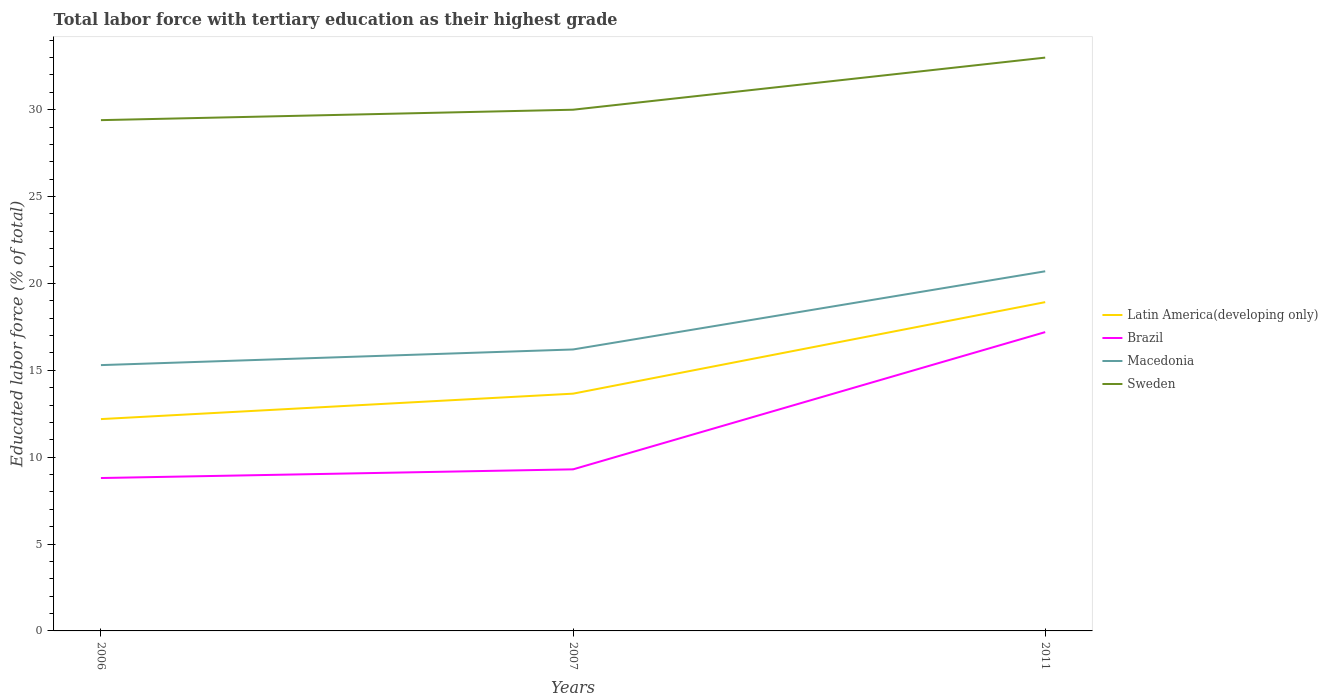How many different coloured lines are there?
Your answer should be very brief. 4. Does the line corresponding to Macedonia intersect with the line corresponding to Brazil?
Offer a terse response. No. Is the number of lines equal to the number of legend labels?
Provide a succinct answer. Yes. Across all years, what is the maximum percentage of male labor force with tertiary education in Brazil?
Offer a terse response. 8.8. What is the total percentage of male labor force with tertiary education in Macedonia in the graph?
Provide a succinct answer. -5.4. What is the difference between the highest and the second highest percentage of male labor force with tertiary education in Latin America(developing only)?
Offer a terse response. 6.73. Is the percentage of male labor force with tertiary education in Macedonia strictly greater than the percentage of male labor force with tertiary education in Sweden over the years?
Your response must be concise. Yes. What is the difference between two consecutive major ticks on the Y-axis?
Your answer should be compact. 5. Are the values on the major ticks of Y-axis written in scientific E-notation?
Make the answer very short. No. Where does the legend appear in the graph?
Keep it short and to the point. Center right. How many legend labels are there?
Your answer should be very brief. 4. What is the title of the graph?
Your answer should be very brief. Total labor force with tertiary education as their highest grade. What is the label or title of the X-axis?
Ensure brevity in your answer.  Years. What is the label or title of the Y-axis?
Your answer should be very brief. Educated labor force (% of total). What is the Educated labor force (% of total) in Latin America(developing only) in 2006?
Give a very brief answer. 12.19. What is the Educated labor force (% of total) in Brazil in 2006?
Offer a terse response. 8.8. What is the Educated labor force (% of total) in Macedonia in 2006?
Offer a terse response. 15.3. What is the Educated labor force (% of total) in Sweden in 2006?
Give a very brief answer. 29.4. What is the Educated labor force (% of total) of Latin America(developing only) in 2007?
Offer a terse response. 13.66. What is the Educated labor force (% of total) in Brazil in 2007?
Your answer should be very brief. 9.3. What is the Educated labor force (% of total) of Macedonia in 2007?
Provide a short and direct response. 16.2. What is the Educated labor force (% of total) in Latin America(developing only) in 2011?
Make the answer very short. 18.92. What is the Educated labor force (% of total) in Brazil in 2011?
Keep it short and to the point. 17.2. What is the Educated labor force (% of total) in Macedonia in 2011?
Your answer should be very brief. 20.7. Across all years, what is the maximum Educated labor force (% of total) of Latin America(developing only)?
Your answer should be compact. 18.92. Across all years, what is the maximum Educated labor force (% of total) of Brazil?
Make the answer very short. 17.2. Across all years, what is the maximum Educated labor force (% of total) of Macedonia?
Keep it short and to the point. 20.7. Across all years, what is the minimum Educated labor force (% of total) of Latin America(developing only)?
Your response must be concise. 12.19. Across all years, what is the minimum Educated labor force (% of total) in Brazil?
Offer a very short reply. 8.8. Across all years, what is the minimum Educated labor force (% of total) of Macedonia?
Offer a very short reply. 15.3. Across all years, what is the minimum Educated labor force (% of total) in Sweden?
Keep it short and to the point. 29.4. What is the total Educated labor force (% of total) of Latin America(developing only) in the graph?
Your response must be concise. 44.77. What is the total Educated labor force (% of total) in Brazil in the graph?
Give a very brief answer. 35.3. What is the total Educated labor force (% of total) of Macedonia in the graph?
Provide a short and direct response. 52.2. What is the total Educated labor force (% of total) in Sweden in the graph?
Make the answer very short. 92.4. What is the difference between the Educated labor force (% of total) of Latin America(developing only) in 2006 and that in 2007?
Your answer should be compact. -1.46. What is the difference between the Educated labor force (% of total) in Macedonia in 2006 and that in 2007?
Offer a very short reply. -0.9. What is the difference between the Educated labor force (% of total) of Sweden in 2006 and that in 2007?
Your answer should be very brief. -0.6. What is the difference between the Educated labor force (% of total) in Latin America(developing only) in 2006 and that in 2011?
Offer a very short reply. -6.73. What is the difference between the Educated labor force (% of total) in Macedonia in 2006 and that in 2011?
Make the answer very short. -5.4. What is the difference between the Educated labor force (% of total) in Sweden in 2006 and that in 2011?
Ensure brevity in your answer.  -3.6. What is the difference between the Educated labor force (% of total) of Latin America(developing only) in 2007 and that in 2011?
Provide a succinct answer. -5.27. What is the difference between the Educated labor force (% of total) of Brazil in 2007 and that in 2011?
Provide a short and direct response. -7.9. What is the difference between the Educated labor force (% of total) of Macedonia in 2007 and that in 2011?
Provide a short and direct response. -4.5. What is the difference between the Educated labor force (% of total) of Latin America(developing only) in 2006 and the Educated labor force (% of total) of Brazil in 2007?
Your answer should be very brief. 2.89. What is the difference between the Educated labor force (% of total) in Latin America(developing only) in 2006 and the Educated labor force (% of total) in Macedonia in 2007?
Provide a short and direct response. -4.01. What is the difference between the Educated labor force (% of total) in Latin America(developing only) in 2006 and the Educated labor force (% of total) in Sweden in 2007?
Your answer should be compact. -17.81. What is the difference between the Educated labor force (% of total) of Brazil in 2006 and the Educated labor force (% of total) of Sweden in 2007?
Your response must be concise. -21.2. What is the difference between the Educated labor force (% of total) of Macedonia in 2006 and the Educated labor force (% of total) of Sweden in 2007?
Offer a very short reply. -14.7. What is the difference between the Educated labor force (% of total) in Latin America(developing only) in 2006 and the Educated labor force (% of total) in Brazil in 2011?
Your answer should be very brief. -5.01. What is the difference between the Educated labor force (% of total) in Latin America(developing only) in 2006 and the Educated labor force (% of total) in Macedonia in 2011?
Give a very brief answer. -8.51. What is the difference between the Educated labor force (% of total) in Latin America(developing only) in 2006 and the Educated labor force (% of total) in Sweden in 2011?
Your response must be concise. -20.81. What is the difference between the Educated labor force (% of total) in Brazil in 2006 and the Educated labor force (% of total) in Macedonia in 2011?
Offer a terse response. -11.9. What is the difference between the Educated labor force (% of total) in Brazil in 2006 and the Educated labor force (% of total) in Sweden in 2011?
Provide a short and direct response. -24.2. What is the difference between the Educated labor force (% of total) of Macedonia in 2006 and the Educated labor force (% of total) of Sweden in 2011?
Provide a short and direct response. -17.7. What is the difference between the Educated labor force (% of total) in Latin America(developing only) in 2007 and the Educated labor force (% of total) in Brazil in 2011?
Ensure brevity in your answer.  -3.54. What is the difference between the Educated labor force (% of total) in Latin America(developing only) in 2007 and the Educated labor force (% of total) in Macedonia in 2011?
Your response must be concise. -7.04. What is the difference between the Educated labor force (% of total) in Latin America(developing only) in 2007 and the Educated labor force (% of total) in Sweden in 2011?
Your answer should be compact. -19.34. What is the difference between the Educated labor force (% of total) of Brazil in 2007 and the Educated labor force (% of total) of Macedonia in 2011?
Your answer should be compact. -11.4. What is the difference between the Educated labor force (% of total) in Brazil in 2007 and the Educated labor force (% of total) in Sweden in 2011?
Give a very brief answer. -23.7. What is the difference between the Educated labor force (% of total) of Macedonia in 2007 and the Educated labor force (% of total) of Sweden in 2011?
Your answer should be very brief. -16.8. What is the average Educated labor force (% of total) in Latin America(developing only) per year?
Your response must be concise. 14.92. What is the average Educated labor force (% of total) in Brazil per year?
Your answer should be very brief. 11.77. What is the average Educated labor force (% of total) in Macedonia per year?
Ensure brevity in your answer.  17.4. What is the average Educated labor force (% of total) of Sweden per year?
Your response must be concise. 30.8. In the year 2006, what is the difference between the Educated labor force (% of total) of Latin America(developing only) and Educated labor force (% of total) of Brazil?
Give a very brief answer. 3.39. In the year 2006, what is the difference between the Educated labor force (% of total) of Latin America(developing only) and Educated labor force (% of total) of Macedonia?
Offer a terse response. -3.11. In the year 2006, what is the difference between the Educated labor force (% of total) of Latin America(developing only) and Educated labor force (% of total) of Sweden?
Give a very brief answer. -17.21. In the year 2006, what is the difference between the Educated labor force (% of total) of Brazil and Educated labor force (% of total) of Macedonia?
Offer a terse response. -6.5. In the year 2006, what is the difference between the Educated labor force (% of total) in Brazil and Educated labor force (% of total) in Sweden?
Ensure brevity in your answer.  -20.6. In the year 2006, what is the difference between the Educated labor force (% of total) in Macedonia and Educated labor force (% of total) in Sweden?
Your answer should be compact. -14.1. In the year 2007, what is the difference between the Educated labor force (% of total) of Latin America(developing only) and Educated labor force (% of total) of Brazil?
Your response must be concise. 4.36. In the year 2007, what is the difference between the Educated labor force (% of total) in Latin America(developing only) and Educated labor force (% of total) in Macedonia?
Your response must be concise. -2.54. In the year 2007, what is the difference between the Educated labor force (% of total) in Latin America(developing only) and Educated labor force (% of total) in Sweden?
Provide a short and direct response. -16.34. In the year 2007, what is the difference between the Educated labor force (% of total) in Brazil and Educated labor force (% of total) in Sweden?
Ensure brevity in your answer.  -20.7. In the year 2011, what is the difference between the Educated labor force (% of total) in Latin America(developing only) and Educated labor force (% of total) in Brazil?
Provide a short and direct response. 1.72. In the year 2011, what is the difference between the Educated labor force (% of total) in Latin America(developing only) and Educated labor force (% of total) in Macedonia?
Provide a short and direct response. -1.78. In the year 2011, what is the difference between the Educated labor force (% of total) in Latin America(developing only) and Educated labor force (% of total) in Sweden?
Offer a terse response. -14.08. In the year 2011, what is the difference between the Educated labor force (% of total) of Brazil and Educated labor force (% of total) of Sweden?
Make the answer very short. -15.8. In the year 2011, what is the difference between the Educated labor force (% of total) in Macedonia and Educated labor force (% of total) in Sweden?
Make the answer very short. -12.3. What is the ratio of the Educated labor force (% of total) of Latin America(developing only) in 2006 to that in 2007?
Offer a very short reply. 0.89. What is the ratio of the Educated labor force (% of total) in Brazil in 2006 to that in 2007?
Offer a very short reply. 0.95. What is the ratio of the Educated labor force (% of total) in Macedonia in 2006 to that in 2007?
Provide a short and direct response. 0.94. What is the ratio of the Educated labor force (% of total) in Sweden in 2006 to that in 2007?
Provide a short and direct response. 0.98. What is the ratio of the Educated labor force (% of total) in Latin America(developing only) in 2006 to that in 2011?
Your response must be concise. 0.64. What is the ratio of the Educated labor force (% of total) in Brazil in 2006 to that in 2011?
Give a very brief answer. 0.51. What is the ratio of the Educated labor force (% of total) in Macedonia in 2006 to that in 2011?
Ensure brevity in your answer.  0.74. What is the ratio of the Educated labor force (% of total) of Sweden in 2006 to that in 2011?
Offer a terse response. 0.89. What is the ratio of the Educated labor force (% of total) of Latin America(developing only) in 2007 to that in 2011?
Keep it short and to the point. 0.72. What is the ratio of the Educated labor force (% of total) of Brazil in 2007 to that in 2011?
Provide a short and direct response. 0.54. What is the ratio of the Educated labor force (% of total) of Macedonia in 2007 to that in 2011?
Give a very brief answer. 0.78. What is the difference between the highest and the second highest Educated labor force (% of total) in Latin America(developing only)?
Your answer should be compact. 5.27. What is the difference between the highest and the second highest Educated labor force (% of total) of Brazil?
Provide a succinct answer. 7.9. What is the difference between the highest and the second highest Educated labor force (% of total) of Sweden?
Your response must be concise. 3. What is the difference between the highest and the lowest Educated labor force (% of total) in Latin America(developing only)?
Provide a succinct answer. 6.73. 